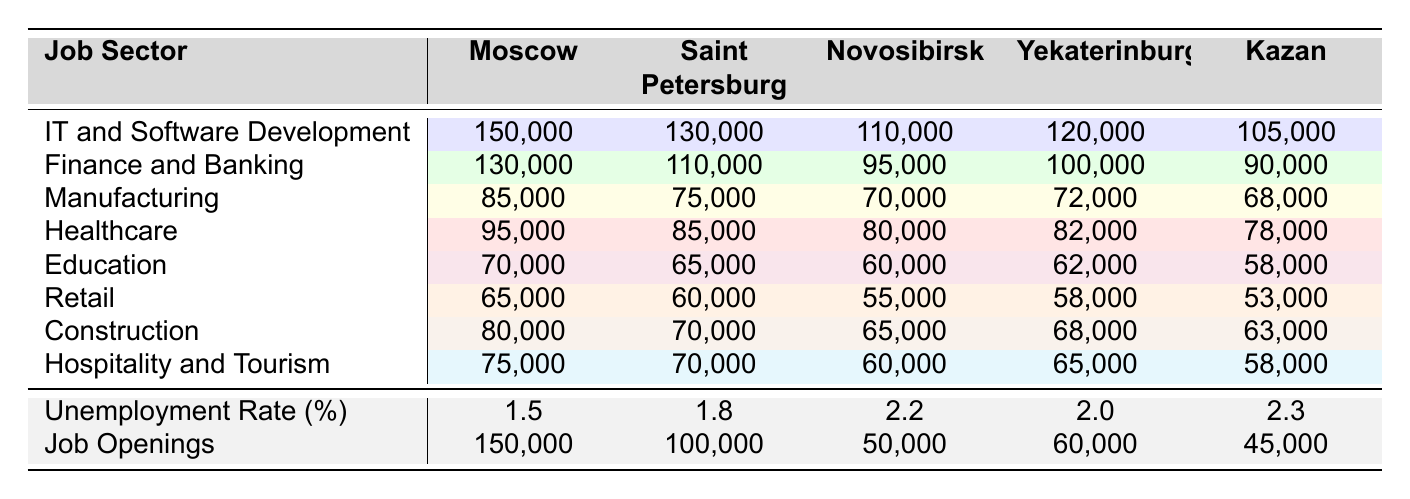What is the average salary for IT and Software Development in Moscow? The table indicates that the average salary for IT and Software Development in Moscow is listed directly; it is 150,000.
Answer: 150,000 Which city has the highest average salary in Healthcare? By comparing the Healthcare salaries across all cities in the table, Moscow has the highest average salary at 95,000.
Answer: Moscow What is the unemployment rate in Kazan? The unemployment rate for Kazan is specified in the data, which shows it is 2.3%.
Answer: 2.3% What is the average salary difference in Manufacturing between Moscow and Saint Petersburg? The average salary in Manufacturing in Moscow is 85,000, while in Saint Petersburg it is 75,000. The difference is calculated as 85,000 - 75,000 = 10,000.
Answer: 10,000 In which sector does Yekaterinburg have the lowest average salary? By reviewing the average salaries for each sector in Yekaterinburg, Retail has the lowest average salary at 58,000.
Answer: Retail How many job openings are available in Novosibirsk? The table indicates that there are 50,000 job openings available in Novosibirsk.
Answer: 50,000 Which city's Finance and Banking sector has the lowest average salary? A comparison of the average salaries in the Finance and Banking sector shows Kazan with the lowest at 90,000.
Answer: Kazan What is the average salary for Education across all listed cities? The Education salaries are 70,000 (Moscow), 65,000 (Saint Petersburg), 60,000 (Novosibirsk), 62,000 (Yekaterinburg), and 58,000 (Kazan). The sum is 70,000 + 65,000 + 60,000 + 62,000 + 58,000 = 315,000, and there are 5 cities, so the average is 315,000 / 5 = 63,000.
Answer: 63,000 Which city has more job openings: Saint Petersburg or Yekaterinburg? According to the data, Saint Petersburg has 100,000 job openings while Yekaterinburg has 60,000. Therefore, Saint Petersburg has more job openings.
Answer: Saint Petersburg If the unemployment rate is higher in Kazan than in Yekaterinburg, is it true? As per the table, Kazan has an unemployment rate of 2.3%, and Yekaterinburg has an unemployment rate of 2.0%. This indicates that Kazan has a higher unemployment rate.
Answer: Yes What is the highest average salary for Construction across the cities? The highest average salary for Construction is found in Moscow at 80,000.
Answer: Moscow 